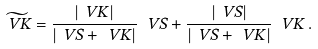<formula> <loc_0><loc_0><loc_500><loc_500>\widetilde { \ V { K } } = \frac { | \ V { K } | } { | \ V { S } + \ V { K } | } \, \ V { S } + \frac { | \ V { S } | } { | \ V { S } + \ V { K } | } \, \ V { K } \, .</formula> 